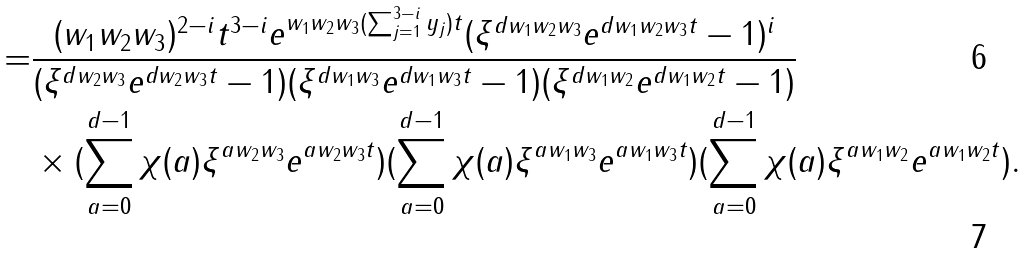<formula> <loc_0><loc_0><loc_500><loc_500>= & \frac { ( w _ { 1 } w _ { 2 } w _ { 3 } ) ^ { 2 - i } t ^ { 3 - i } e ^ { w _ { 1 } w _ { 2 } w _ { 3 } ( \sum _ { j = 1 } ^ { 3 - i } y _ { j } ) t } ( \xi ^ { d w _ { 1 } w _ { 2 } w _ { 3 } } e ^ { d w _ { 1 } w _ { 2 } w _ { 3 } t } - 1 ) ^ { i } } { ( \xi ^ { d w _ { 2 } w _ { 3 } } e ^ { d w _ { 2 } w _ { 3 } t } - 1 ) ( \xi ^ { d w _ { 1 } w _ { 3 } } e ^ { d w _ { 1 } w _ { 3 } t } - 1 ) ( \xi ^ { d w _ { 1 } w _ { 2 } } e ^ { d w _ { 1 } w _ { 2 } t } - 1 ) } \\ & \times ( \sum _ { a = 0 } ^ { d - 1 } \chi ( a ) \xi ^ { a w _ { 2 } w _ { 3 } } e ^ { a w _ { 2 } w _ { 3 } t } ) ( \sum _ { a = 0 } ^ { d - 1 } \chi ( a ) \xi ^ { a w _ { 1 } w _ { 3 } } e ^ { a w _ { 1 } w _ { 3 } t } ) ( \sum _ { a = 0 } ^ { d - 1 } \chi ( a ) \xi ^ { a w _ { 1 } w _ { 2 } } e ^ { a w _ { 1 } w _ { 2 } t } ) .</formula> 